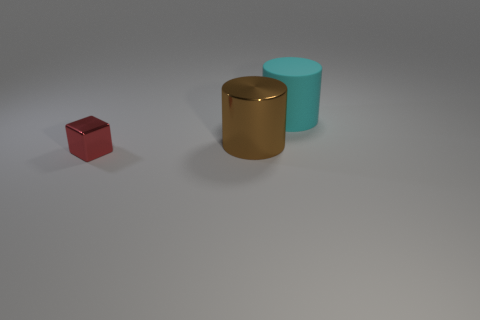Is the metallic cylinder the same size as the red metal object?
Offer a very short reply. No. Do the tiny metal object and the cyan thing have the same shape?
Ensure brevity in your answer.  No. There is a small metal thing; are there any cylinders behind it?
Your response must be concise. Yes. How many objects are either small red objects or big red cylinders?
Your response must be concise. 1. What number of other things are there of the same size as the metallic cube?
Provide a short and direct response. 0. How many things are both to the right of the shiny cube and to the left of the rubber object?
Ensure brevity in your answer.  1. Is the size of the metallic object that is behind the small metallic cube the same as the thing behind the large brown metal cylinder?
Your answer should be compact. Yes. There is a cylinder in front of the large cyan matte cylinder; what size is it?
Provide a short and direct response. Large. What number of objects are cylinders that are in front of the large cyan thing or things that are in front of the big cyan cylinder?
Provide a short and direct response. 2. Is the number of cylinders on the left side of the large brown metal cylinder the same as the number of matte things that are to the left of the big cyan object?
Keep it short and to the point. Yes. 